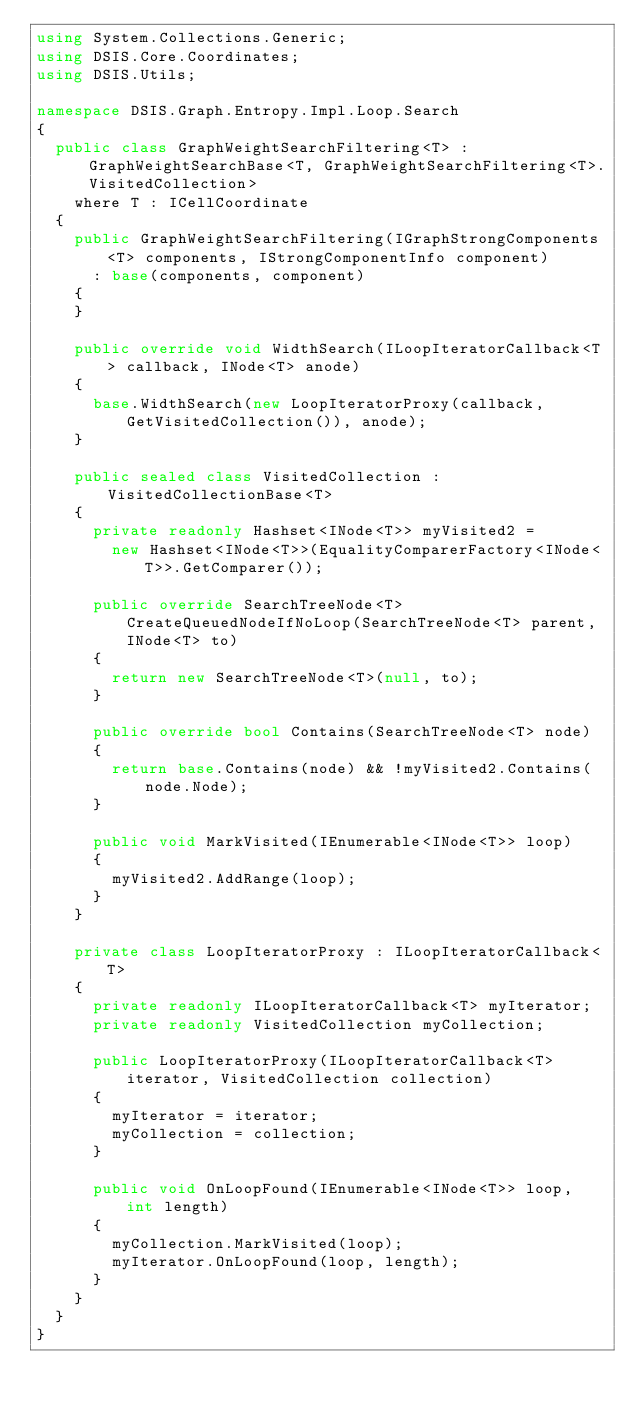<code> <loc_0><loc_0><loc_500><loc_500><_C#_>using System.Collections.Generic;
using DSIS.Core.Coordinates;
using DSIS.Utils;

namespace DSIS.Graph.Entropy.Impl.Loop.Search
{
  public class GraphWeightSearchFiltering<T> : GraphWeightSearchBase<T, GraphWeightSearchFiltering<T>.VisitedCollection>
    where T : ICellCoordinate
  {
    public GraphWeightSearchFiltering(IGraphStrongComponents<T> components, IStrongComponentInfo component)
      : base(components, component)
    {
    }

    public override void WidthSearch(ILoopIteratorCallback<T> callback, INode<T> anode)
    {
      base.WidthSearch(new LoopIteratorProxy(callback, GetVisitedCollection()), anode);
    }

    public sealed class VisitedCollection : VisitedCollectionBase<T>
    {
      private readonly Hashset<INode<T>> myVisited2 =
        new Hashset<INode<T>>(EqualityComparerFactory<INode<T>>.GetComparer());

      public override SearchTreeNode<T> CreateQueuedNodeIfNoLoop(SearchTreeNode<T> parent, INode<T> to)
      {
        return new SearchTreeNode<T>(null, to);
      }

      public override bool Contains(SearchTreeNode<T> node)
      {
        return base.Contains(node) && !myVisited2.Contains(node.Node);
      }

      public void MarkVisited(IEnumerable<INode<T>> loop)
      {
        myVisited2.AddRange(loop);
      }
    }

    private class LoopIteratorProxy : ILoopIteratorCallback<T>
    {
      private readonly ILoopIteratorCallback<T> myIterator;
      private readonly VisitedCollection myCollection;

      public LoopIteratorProxy(ILoopIteratorCallback<T> iterator, VisitedCollection collection)
      {
        myIterator = iterator;
        myCollection = collection;
      }

      public void OnLoopFound(IEnumerable<INode<T>> loop, int length)
      {
        myCollection.MarkVisited(loop);
        myIterator.OnLoopFound(loop, length);
      }
    }
  }
}</code> 